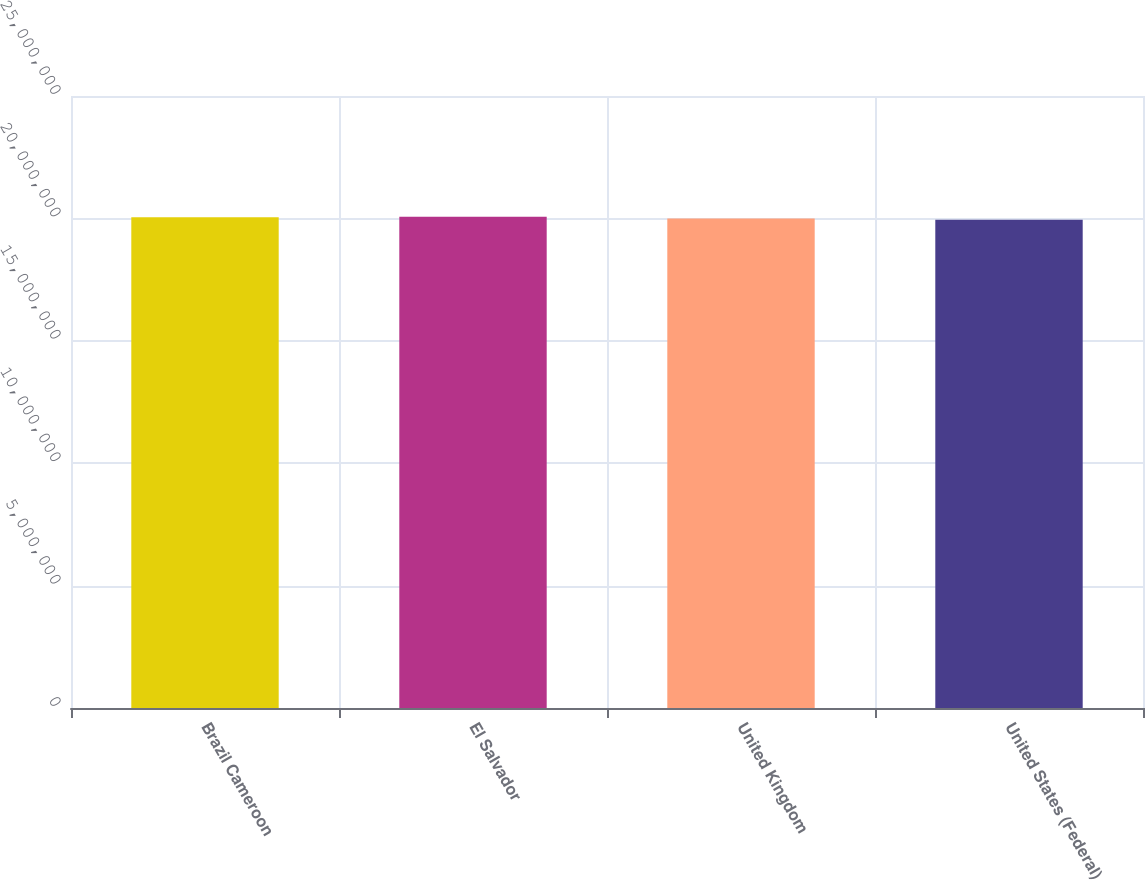<chart> <loc_0><loc_0><loc_500><loc_500><bar_chart><fcel>Brazil Cameroon<fcel>El Salvador<fcel>United Kingdom<fcel>United States (Federal)<nl><fcel>2.0052e+07<fcel>2.0072e+07<fcel>1.9992e+07<fcel>1.9942e+07<nl></chart> 